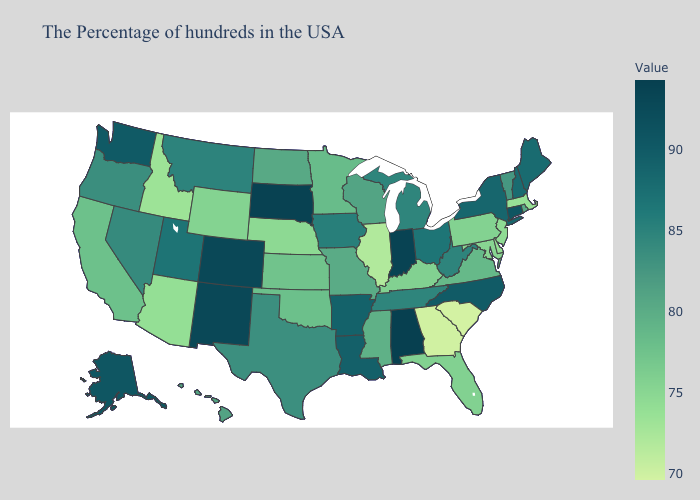Does Virginia have the highest value in the South?
Short answer required. No. Among the states that border Louisiana , does Texas have the lowest value?
Answer briefly. No. Among the states that border Indiana , does Ohio have the lowest value?
Be succinct. No. Does the map have missing data?
Be succinct. No. Which states have the lowest value in the West?
Quick response, please. Idaho. Which states hav the highest value in the West?
Be succinct. Colorado, New Mexico. Is the legend a continuous bar?
Be succinct. Yes. 